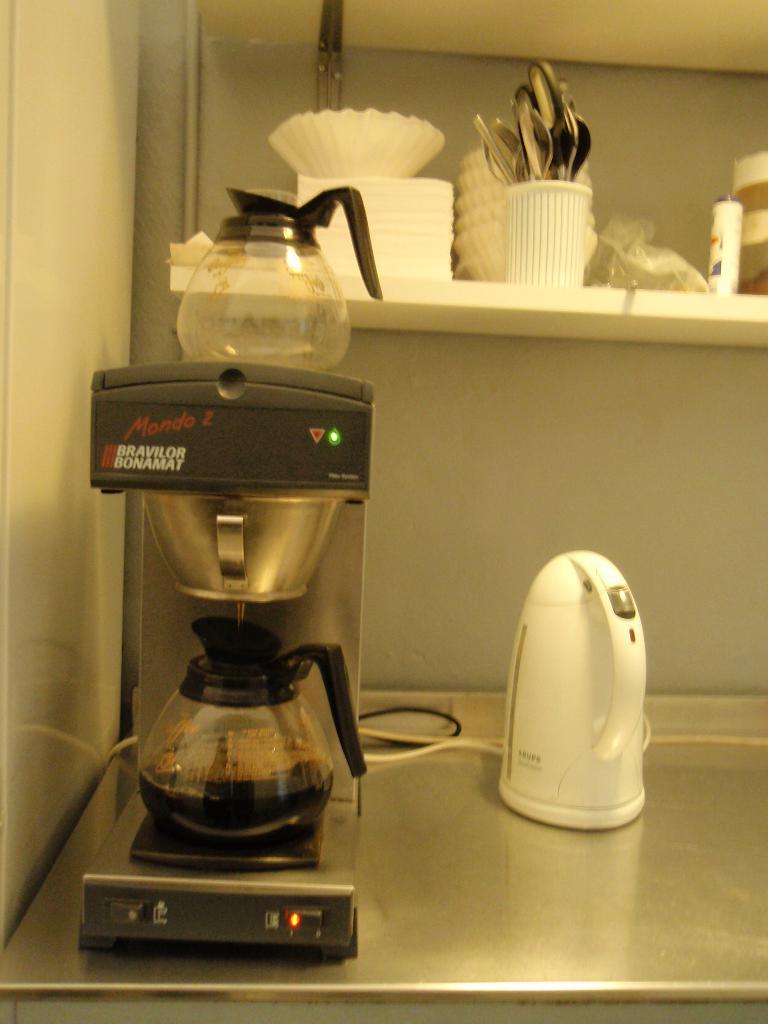What is the name of this coffee machine (written in red)?
Your answer should be compact. Mondo 2. Does the machine say bonamat?
Offer a very short reply. Yes. 